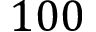<formula> <loc_0><loc_0><loc_500><loc_500>1 0 0</formula> 